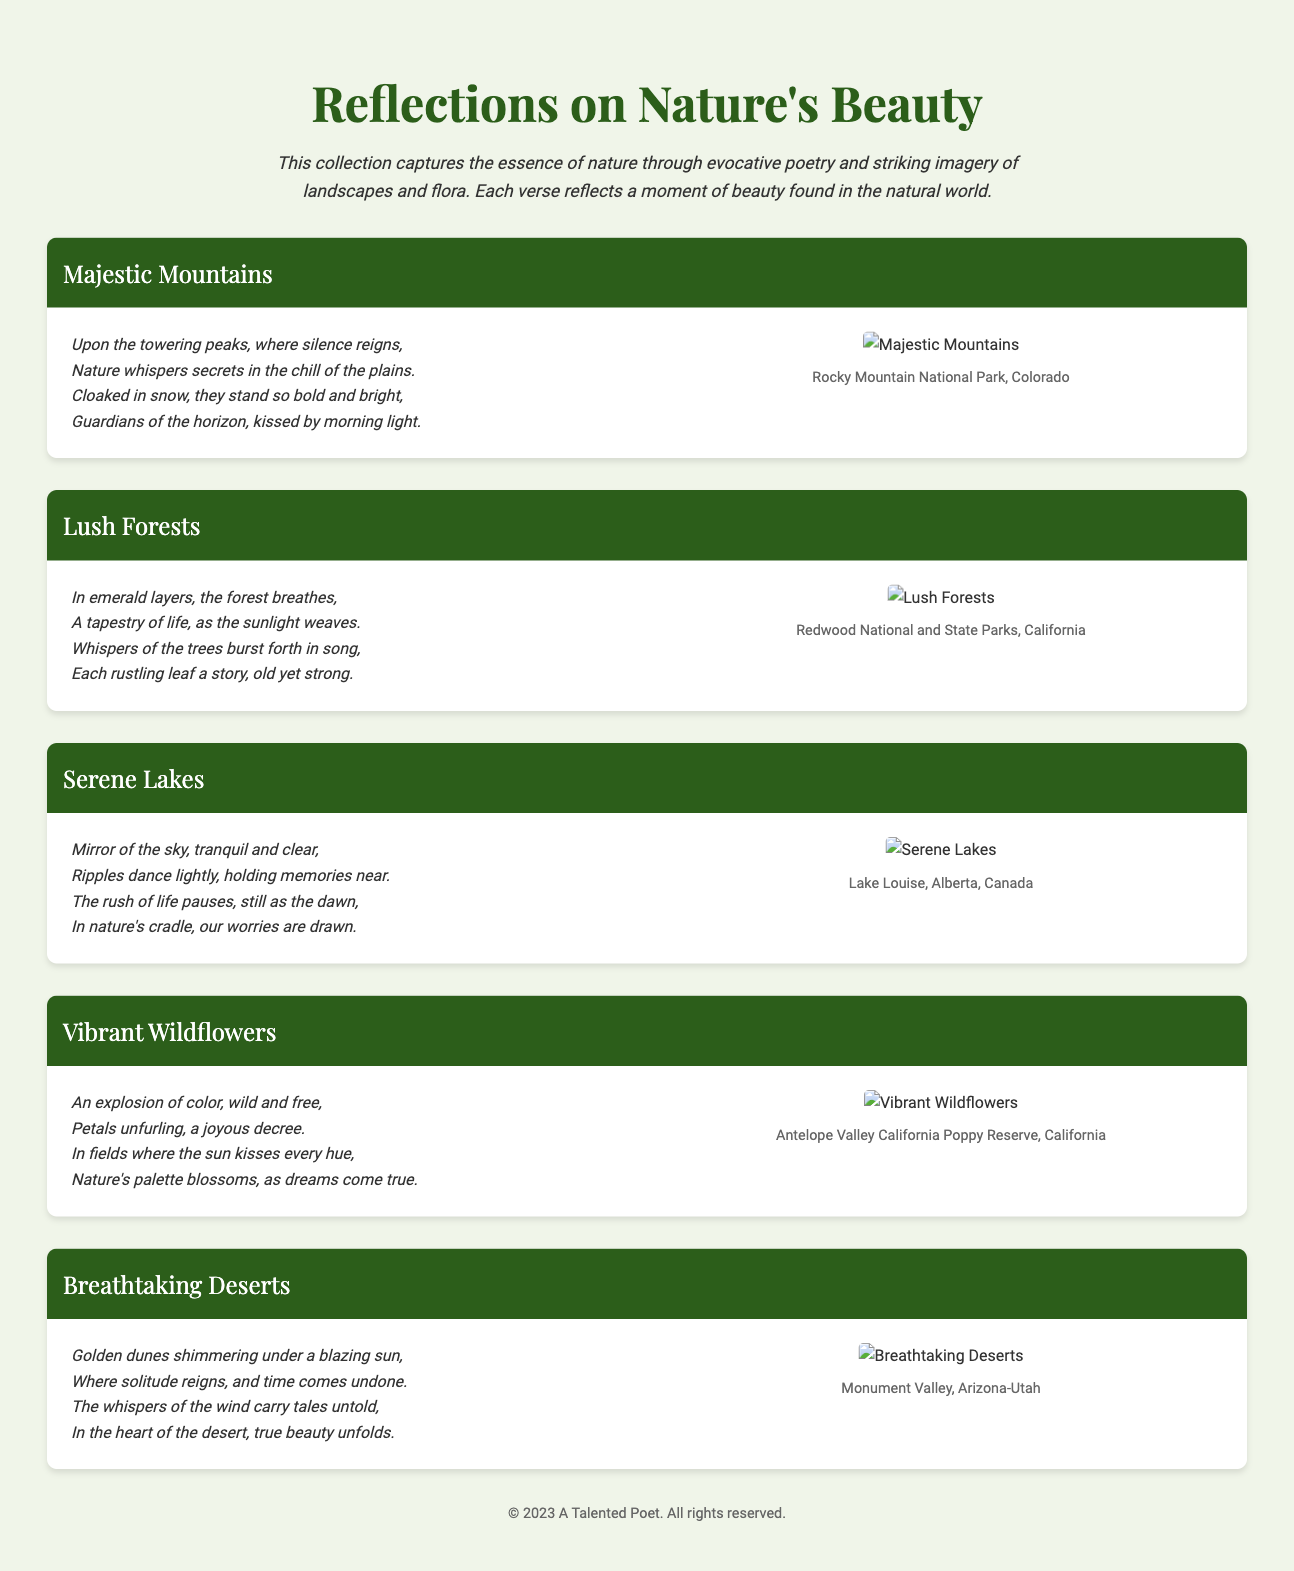What is the title of the collection? The title is specified at the beginning of the document in the header section.
Answer: Reflections on Nature's Beauty How many sections are there in the document? The document contains several sections, each dedicated to a different aspect of nature.
Answer: Five What is the location of the "Majestic Mountains"? Each section includes a location for the image described. The location of the "Majestic Mountains" is mentioned in the respective section.
Answer: Rocky Mountain National Park, Colorado What kind of flora is featured in the "Vibrant Wildflowers" section? This section describes wildflowers, which are a type of flora.
Answer: Wildflowers Which section includes a poem about lakes? The section mentions serene lakes in its title and contains a dedicated poem regarding that topic.
Answer: Serene Lakes What natural feature is highlighted in the "Breathtaking Deserts" poem? The poem focuses on the characteristics of deserts, specifically mentioning golden dunes and beauty.
Answer: Deserts Who is the author of the collection? The footer of the document provides the name attribution for this collection of works.
Answer: A Talented Poet What is the main theme of the collection? The overall theme is indicated in the introduction, suggesting a focus on nature's beauty through poetry and imagery.
Answer: Nature's beauty 